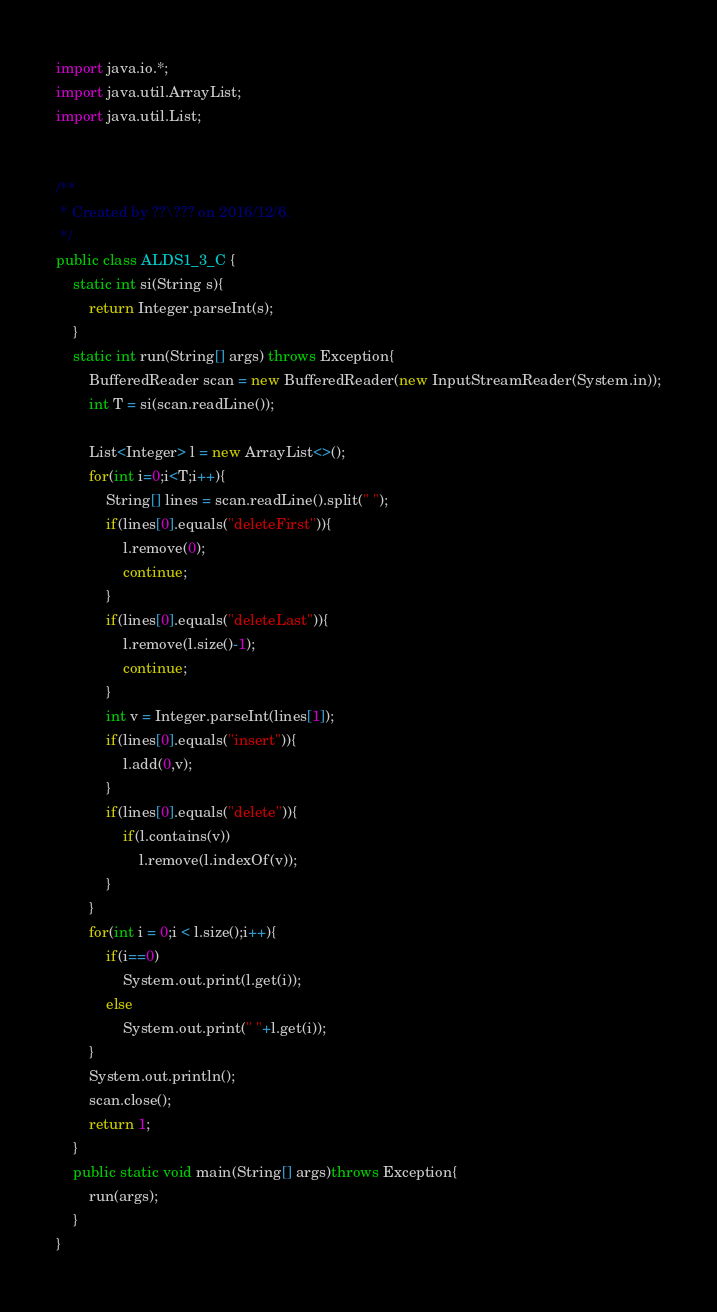<code> <loc_0><loc_0><loc_500><loc_500><_Java_>

import java.io.*;
import java.util.ArrayList;
import java.util.List;


/**
 * Created by ??\??? on 2016/12/6.
 */
public class ALDS1_3_C {
    static int si(String s){
        return Integer.parseInt(s);
    }
    static int run(String[] args) throws Exception{
        BufferedReader scan = new BufferedReader(new InputStreamReader(System.in));
        int T = si(scan.readLine());

        List<Integer> l = new ArrayList<>();
        for(int i=0;i<T;i++){
            String[] lines = scan.readLine().split(" ");
            if(lines[0].equals("deleteFirst")){
                l.remove(0);
                continue;
            }
            if(lines[0].equals("deleteLast")){
                l.remove(l.size()-1);
                continue;
            }
            int v = Integer.parseInt(lines[1]);
            if(lines[0].equals("insert")){
                l.add(0,v);
            }
            if(lines[0].equals("delete")){
                if(l.contains(v))
                    l.remove(l.indexOf(v));
            }
        }
        for(int i = 0;i < l.size();i++){
            if(i==0)
                System.out.print(l.get(i));
            else
                System.out.print(" "+l.get(i));
        }
        System.out.println();
        scan.close();
        return 1;
    }
    public static void main(String[] args)throws Exception{
        run(args);
    }
}</code> 